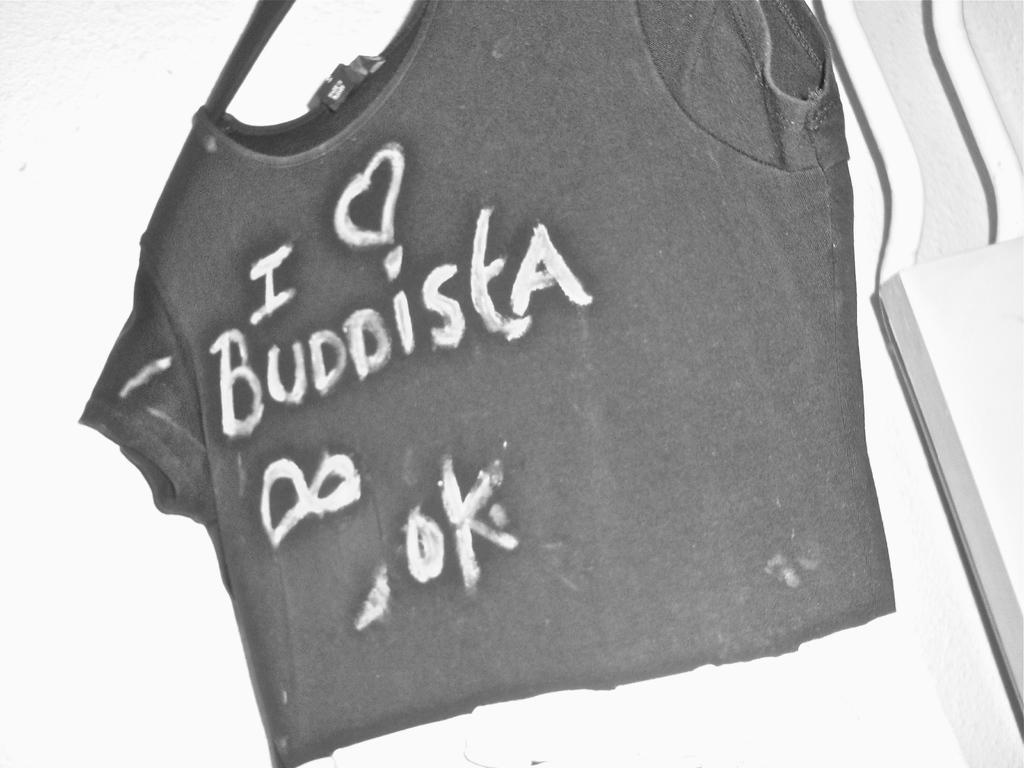What type of clothing item is in the image? There is a T-shirt in the image. How is the T-shirt positioned in the image? The T-shirt is on a hanger. What can be seen on the T-shirt? There is text on the T-shirt. Can you see the father working on the farm in the image? There is no father or farm present in the image; it only features a T-shirt on a hanger with text. How many wrens are perched on the T-shirt in the image? There are no wrens present in the image; it only features a T-shirt on a hanger with text. 